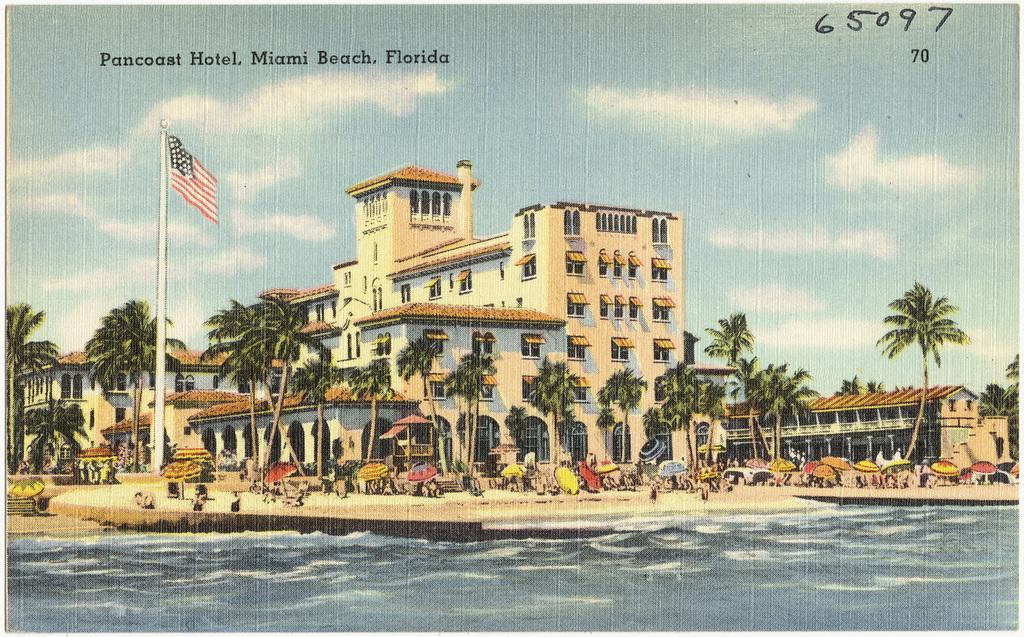How would you summarize this image in a sentence or two? In this image we can see a photo. In this image we can see buildings, flag, trees, umbrellas and other objects. At the top of the image there is the sky. At the bottom of the image there is water. On the image there are some text and numbers. 